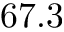<formula> <loc_0><loc_0><loc_500><loc_500>6 7 . 3</formula> 